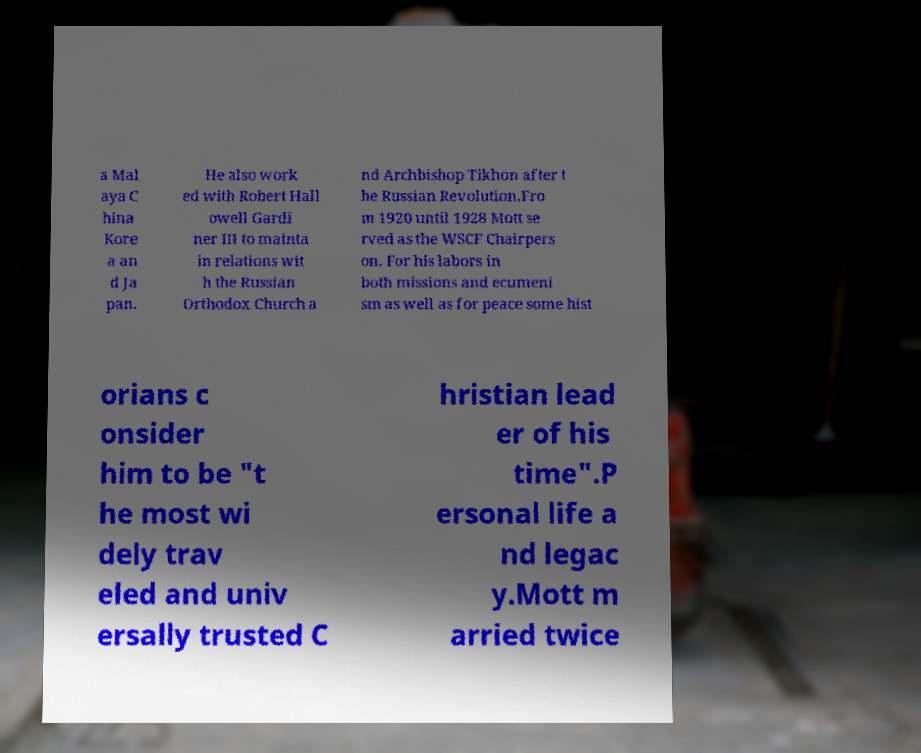Could you extract and type out the text from this image? a Mal aya C hina Kore a an d Ja pan. He also work ed with Robert Hall owell Gardi ner III to mainta in relations wit h the Russian Orthodox Church a nd Archbishop Tikhon after t he Russian Revolution.Fro m 1920 until 1928 Mott se rved as the WSCF Chairpers on. For his labors in both missions and ecumeni sm as well as for peace some hist orians c onsider him to be "t he most wi dely trav eled and univ ersally trusted C hristian lead er of his time".P ersonal life a nd legac y.Mott m arried twice 